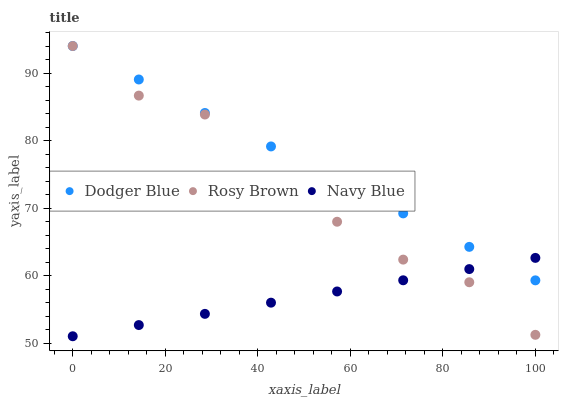Does Navy Blue have the minimum area under the curve?
Answer yes or no. Yes. Does Dodger Blue have the maximum area under the curve?
Answer yes or no. Yes. Does Rosy Brown have the minimum area under the curve?
Answer yes or no. No. Does Rosy Brown have the maximum area under the curve?
Answer yes or no. No. Is Dodger Blue the smoothest?
Answer yes or no. Yes. Is Rosy Brown the roughest?
Answer yes or no. Yes. Is Rosy Brown the smoothest?
Answer yes or no. No. Is Dodger Blue the roughest?
Answer yes or no. No. Does Navy Blue have the lowest value?
Answer yes or no. Yes. Does Rosy Brown have the lowest value?
Answer yes or no. No. Does Dodger Blue have the highest value?
Answer yes or no. Yes. Does Rosy Brown intersect Navy Blue?
Answer yes or no. Yes. Is Rosy Brown less than Navy Blue?
Answer yes or no. No. Is Rosy Brown greater than Navy Blue?
Answer yes or no. No. 